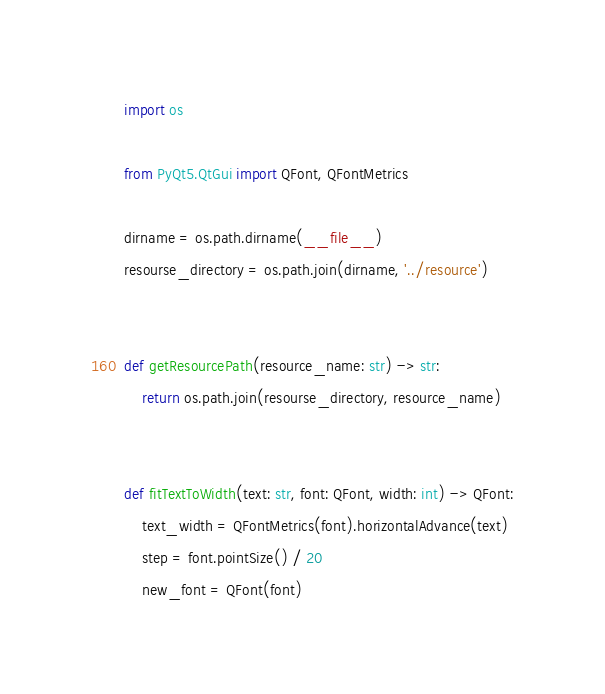<code> <loc_0><loc_0><loc_500><loc_500><_Python_>import os

from PyQt5.QtGui import QFont, QFontMetrics

dirname = os.path.dirname(__file__)
resourse_directory = os.path.join(dirname, '../resource')


def getResourcePath(resource_name: str) -> str:
    return os.path.join(resourse_directory, resource_name)


def fitTextToWidth(text: str, font: QFont, width: int) -> QFont:
    text_width = QFontMetrics(font).horizontalAdvance(text)
    step = font.pointSize() / 20
    new_font = QFont(font)
</code> 